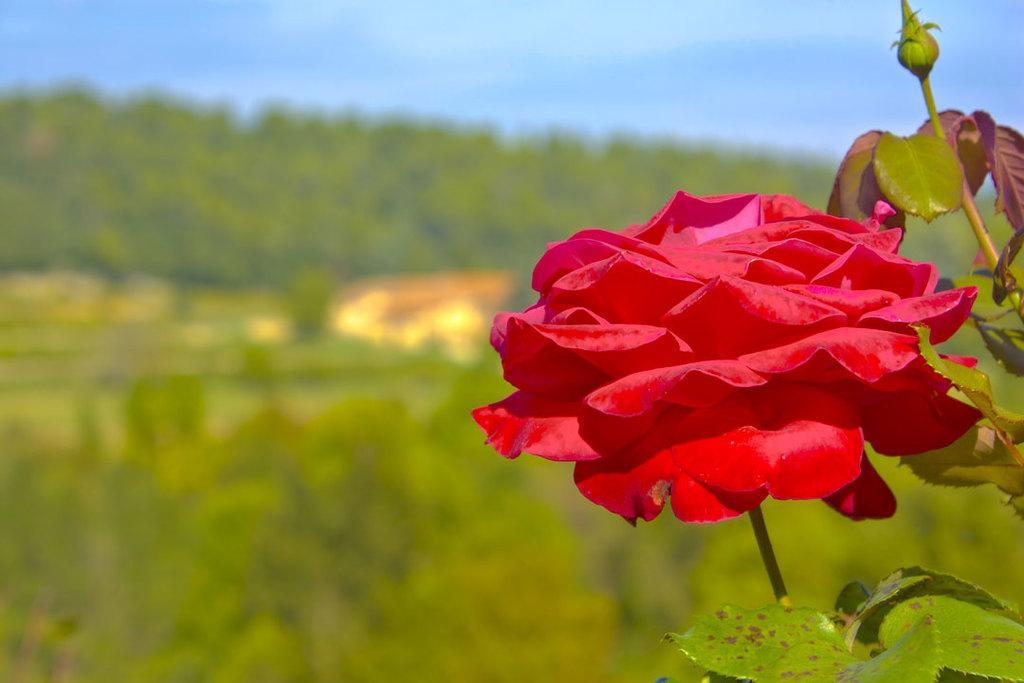Can you describe this image briefly? In the image we can see the flower, red in color. Here we can see leaves, the sky and the background is blurred. 